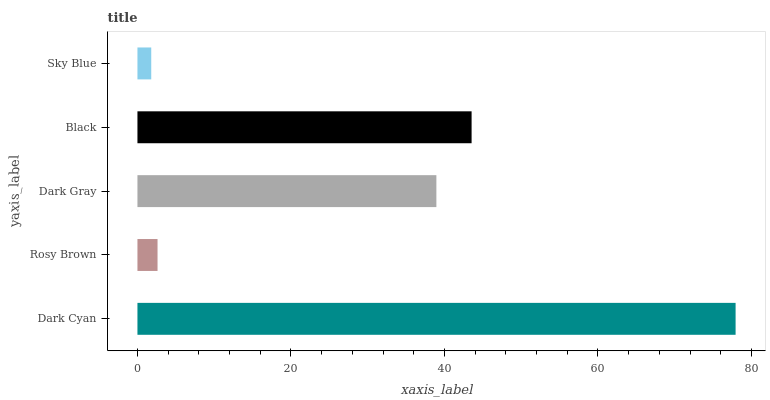Is Sky Blue the minimum?
Answer yes or no. Yes. Is Dark Cyan the maximum?
Answer yes or no. Yes. Is Rosy Brown the minimum?
Answer yes or no. No. Is Rosy Brown the maximum?
Answer yes or no. No. Is Dark Cyan greater than Rosy Brown?
Answer yes or no. Yes. Is Rosy Brown less than Dark Cyan?
Answer yes or no. Yes. Is Rosy Brown greater than Dark Cyan?
Answer yes or no. No. Is Dark Cyan less than Rosy Brown?
Answer yes or no. No. Is Dark Gray the high median?
Answer yes or no. Yes. Is Dark Gray the low median?
Answer yes or no. Yes. Is Sky Blue the high median?
Answer yes or no. No. Is Black the low median?
Answer yes or no. No. 